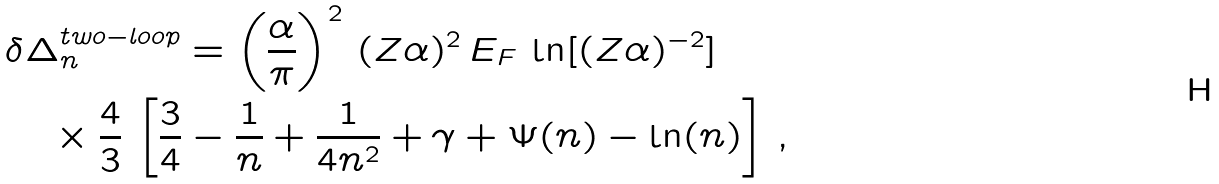<formula> <loc_0><loc_0><loc_500><loc_500>& \delta \Delta _ { n } ^ { t w o - l o o p } = \left ( \frac { \alpha } { \pi } \right ) ^ { 2 } \, ( Z \alpha ) ^ { 2 } \, E _ { F } \, \ln [ ( Z \alpha ) ^ { - 2 } ] \, \\ & \quad \times \frac { 4 } { 3 } \, \left [ \frac { 3 } { 4 } - \frac { 1 } { n } + \frac { 1 } { 4 n ^ { 2 } } + \gamma + \Psi ( n ) - \ln ( n ) \right ] \, ,</formula> 